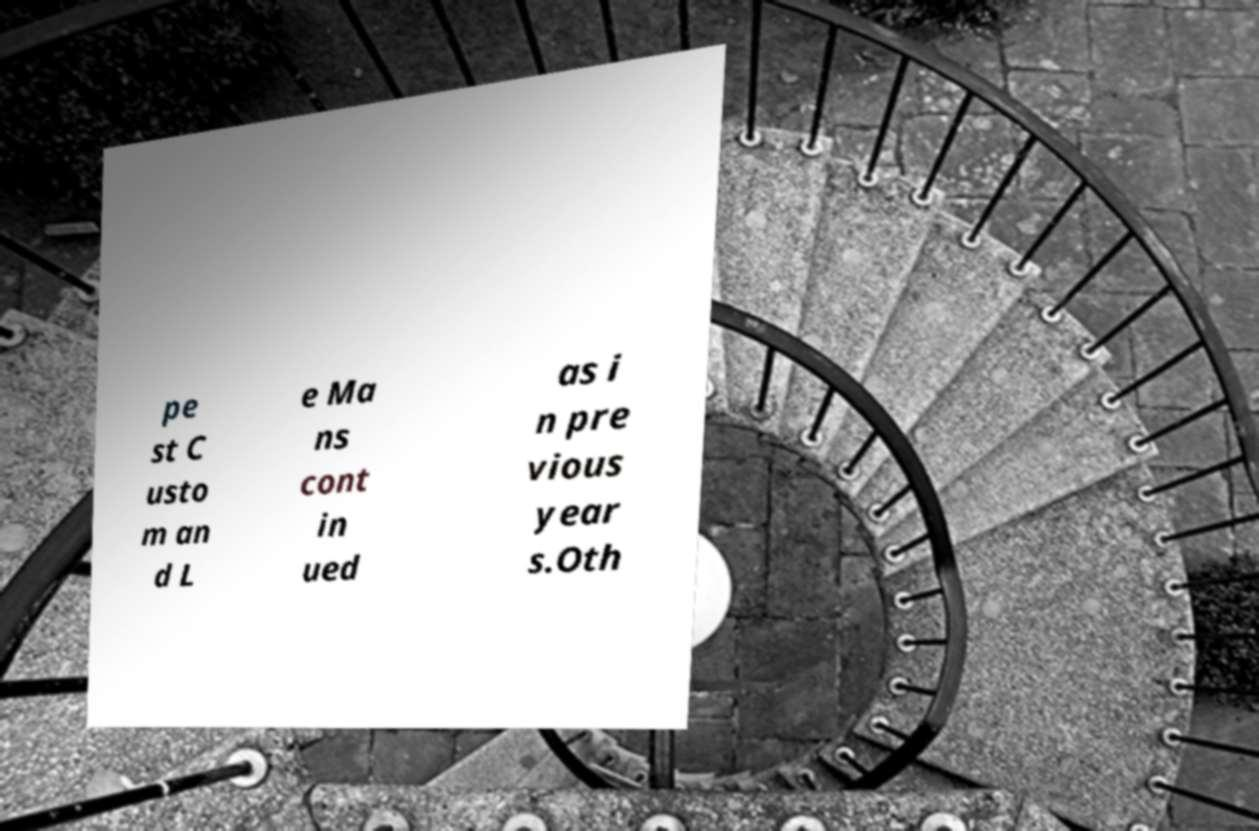Could you extract and type out the text from this image? pe st C usto m an d L e Ma ns cont in ued as i n pre vious year s.Oth 